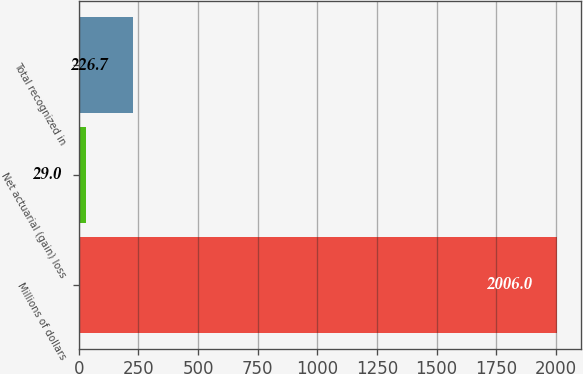<chart> <loc_0><loc_0><loc_500><loc_500><bar_chart><fcel>Millions of dollars<fcel>Net actuarial (gain) loss<fcel>Total recognized in<nl><fcel>2006<fcel>29<fcel>226.7<nl></chart> 